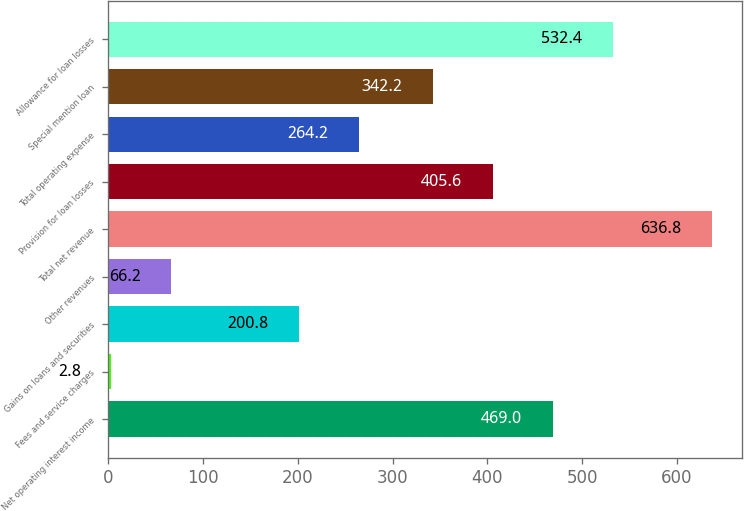<chart> <loc_0><loc_0><loc_500><loc_500><bar_chart><fcel>Net operating interest income<fcel>Fees and service charges<fcel>Gains on loans and securities<fcel>Other revenues<fcel>Total net revenue<fcel>Provision for loan losses<fcel>Total operating expense<fcel>Special mention loan<fcel>Allowance for loan losses<nl><fcel>469<fcel>2.8<fcel>200.8<fcel>66.2<fcel>636.8<fcel>405.6<fcel>264.2<fcel>342.2<fcel>532.4<nl></chart> 